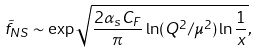Convert formula to latex. <formula><loc_0><loc_0><loc_500><loc_500>\tilde { f } _ { N S } \sim \exp \sqrt { \frac { 2 \alpha _ { s } C _ { F } } { \pi } \ln ( Q ^ { 2 } / \mu ^ { 2 } ) \ln \frac { 1 } { x } } ,</formula> 